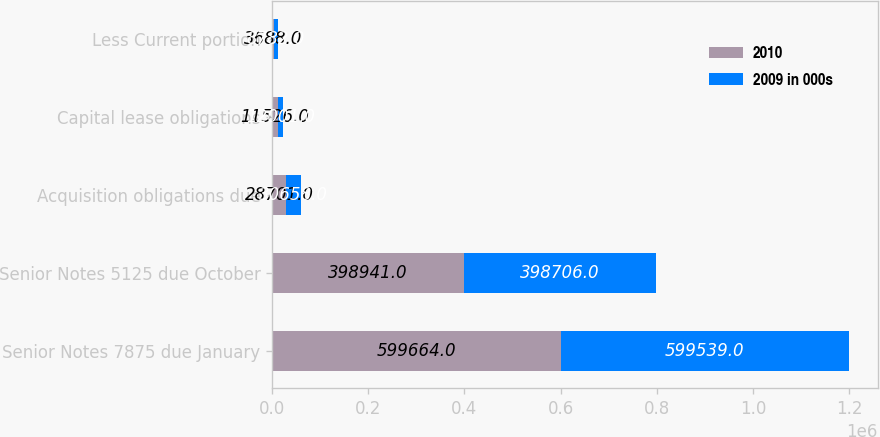<chart> <loc_0><loc_0><loc_500><loc_500><stacked_bar_chart><ecel><fcel>Senior Notes 7875 due January<fcel>Senior Notes 5125 due October<fcel>Acquisition obligations due<fcel>Capital lease obligations<fcel>Less Current portion<nl><fcel>2010<fcel>599664<fcel>398941<fcel>28701<fcel>11526<fcel>3688<nl><fcel>2009 in 000s<fcel>599539<fcel>398706<fcel>30658<fcel>12001<fcel>8782<nl></chart> 